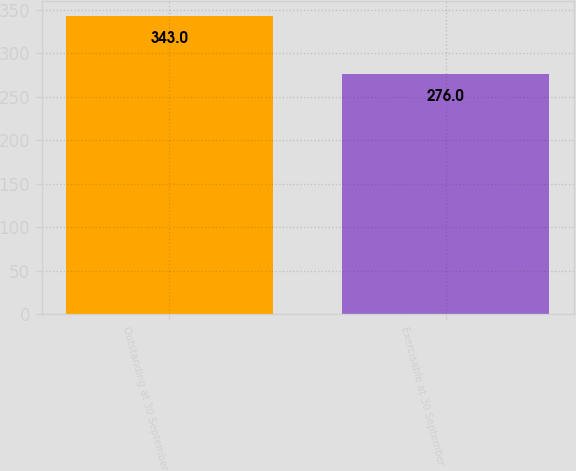Convert chart to OTSL. <chart><loc_0><loc_0><loc_500><loc_500><bar_chart><fcel>Outstanding at 30 September<fcel>Exercisable at 30 September<nl><fcel>343<fcel>276<nl></chart> 